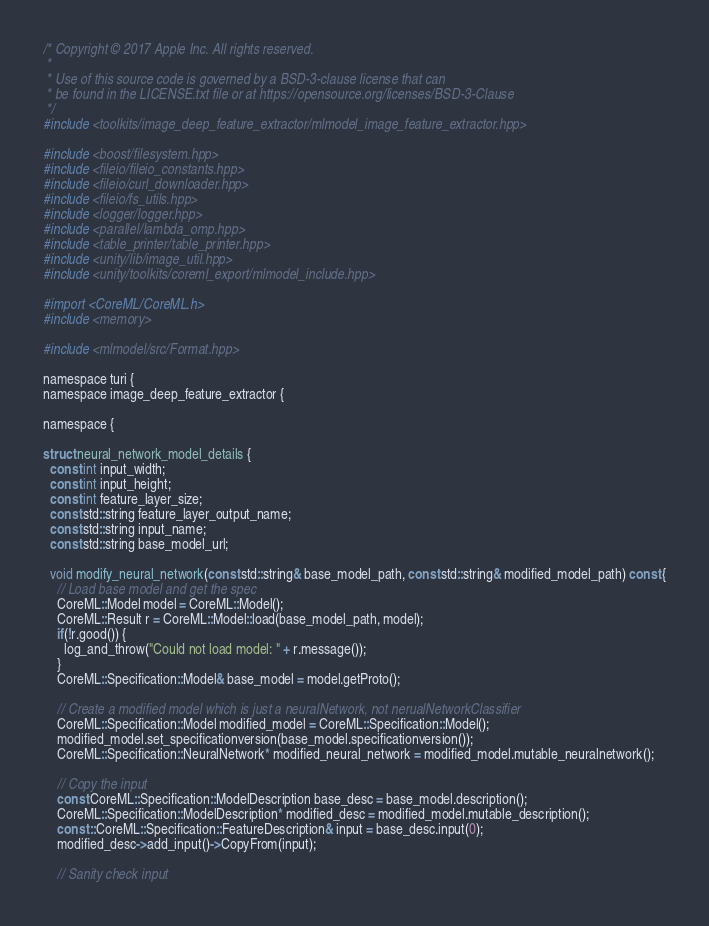<code> <loc_0><loc_0><loc_500><loc_500><_ObjectiveC_>/* Copyright © 2017 Apple Inc. All rights reserved.
 *
 * Use of this source code is governed by a BSD-3-clause license that can
 * be found in the LICENSE.txt file or at https://opensource.org/licenses/BSD-3-Clause
 */
#include <toolkits/image_deep_feature_extractor/mlmodel_image_feature_extractor.hpp>

#include <boost/filesystem.hpp>
#include <fileio/fileio_constants.hpp>
#include <fileio/curl_downloader.hpp>
#include <fileio/fs_utils.hpp>
#include <logger/logger.hpp>
#include <parallel/lambda_omp.hpp>
#include <table_printer/table_printer.hpp>
#include <unity/lib/image_util.hpp>
#include <unity/toolkits/coreml_export/mlmodel_include.hpp>

#import <CoreML/CoreML.h>
#include <memory>

#include <mlmodel/src/Format.hpp>

namespace turi {
namespace image_deep_feature_extractor {

namespace {

struct neural_network_model_details {
  const int input_width;
  const int input_height;
  const int feature_layer_size;
  const std::string feature_layer_output_name;
  const std::string input_name;
  const std::string base_model_url;

  void modify_neural_network(const std::string& base_model_path, const std::string& modified_model_path) const {
    // Load base model and get the spec
    CoreML::Model model = CoreML::Model();
    CoreML::Result r = CoreML::Model::load(base_model_path, model);
    if(!r.good()) {
      log_and_throw("Could not load model: " + r.message());
    }
    CoreML::Specification::Model& base_model = model.getProto();

    // Create a modified model which is just a neuralNetwork, not nerualNetworkClassifier
    CoreML::Specification::Model modified_model = CoreML::Specification::Model();
    modified_model.set_specificationversion(base_model.specificationversion());
    CoreML::Specification::NeuralNetwork* modified_neural_network = modified_model.mutable_neuralnetwork();

    // Copy the input
    const CoreML::Specification::ModelDescription base_desc = base_model.description();
    CoreML::Specification::ModelDescription* modified_desc = modified_model.mutable_description();
    const ::CoreML::Specification::FeatureDescription& input = base_desc.input(0);
    modified_desc->add_input()->CopyFrom(input);

    // Sanity check input</code> 